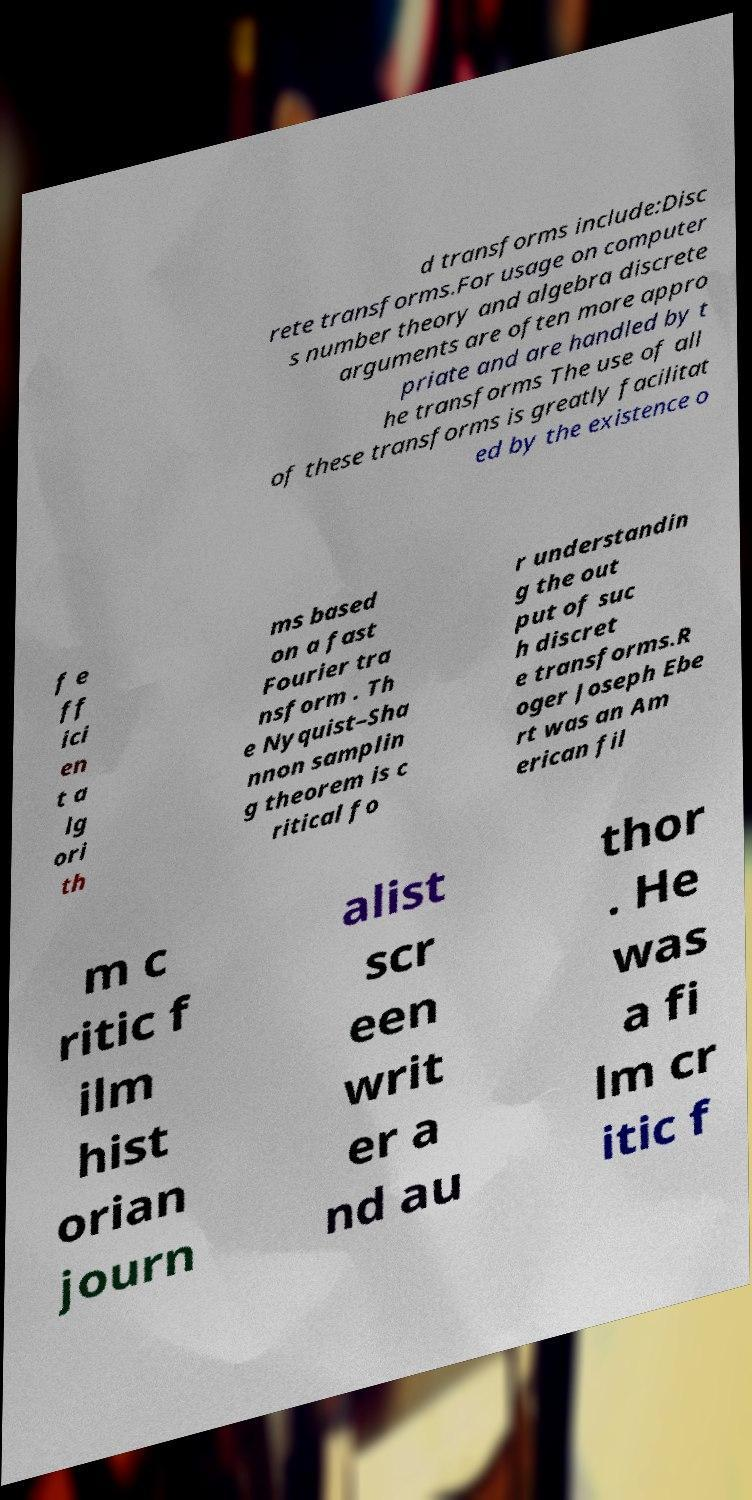Please read and relay the text visible in this image. What does it say? d transforms include:Disc rete transforms.For usage on computer s number theory and algebra discrete arguments are often more appro priate and are handled by t he transforms The use of all of these transforms is greatly facilitat ed by the existence o f e ff ici en t a lg ori th ms based on a fast Fourier tra nsform . Th e Nyquist–Sha nnon samplin g theorem is c ritical fo r understandin g the out put of suc h discret e transforms.R oger Joseph Ebe rt was an Am erican fil m c ritic f ilm hist orian journ alist scr een writ er a nd au thor . He was a fi lm cr itic f 